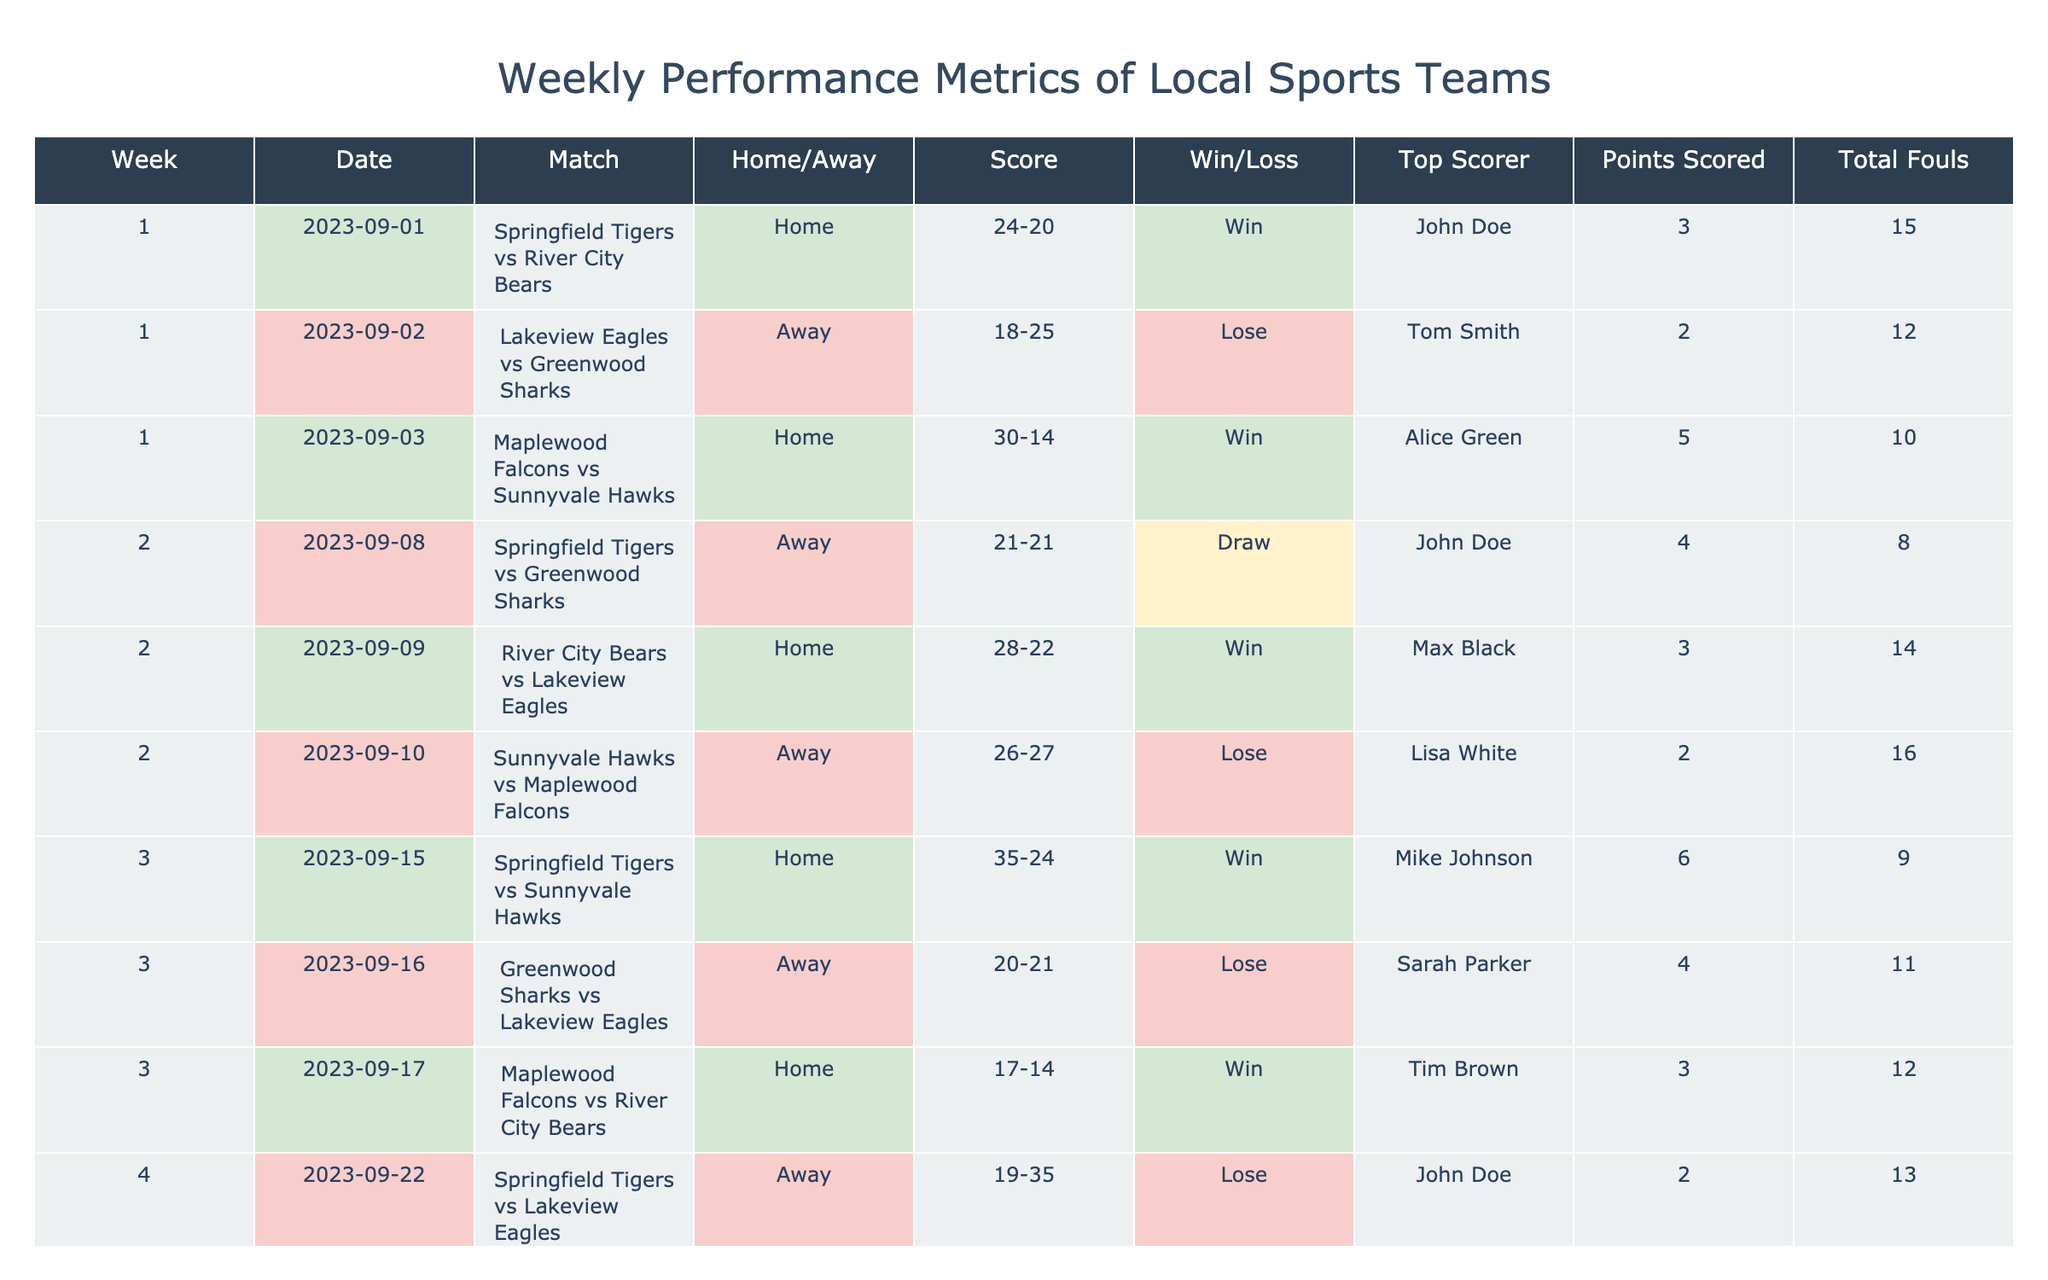What was the score of the Springfield Tigers' game against the River City Bears in Week 1? In Week 1, the Springfield Tigers played against the River City Bears, and the score listed is 24-20.
Answer: 24-20 Which team had the highest number of points scored in a single game? The Maplewood Falcons scored the highest points in a single game, with 30 points against the Sunnyvale Hawks in Week 1.
Answer: 30 Did the Lakeview Eagles win more games than they lost? The Lakeview Eagles had a total of 5 games, winning 2 and losing 3. Therefore, they lost more games than they won.
Answer: No What is the average points scored by the Springfield Tigers across all their games? The Springfield Tigers scored 24, 21, 35, 19, and 20 points in their 5 games. Summing these gives 24 + 21 + 35 + 19 + 20 = 119. Dividing by 5, the average is 119/5 = 23.8.
Answer: 23.8 In how many games did the top scorer score more than 3 points? The top scorer scored more than 3 points in 3 games: Mike Johnson scored 6 points in Week 3, Sarah Parker scored 6 points in Week 5, and John Doe scored 4 points in Week 2.
Answer: 3 Which team had the fewest total fouls in their matches? The team with the fewest total fouls is the River City Bears, with a total of 7 fouls accumulated across their games.
Answer: 7 How many games did the Springfield Tigers play at home, and what was their win-loss record in those matches? The Springfield Tigers played 3 games at home: against the River City Bears (Win), Sunnyvale Hawks (Win), and Lakeview Eagles (Lose), resulting in 2 wins and 1 loss.
Answer: 2-1 What was the outcome of the Maplewood Falcons' game against the Sunnyvale Hawks in Week 2? The Maplewood Falcons played against the Sunnyvale Hawks in Week 2 and the outcome was a loss, with the score being 26-27.
Answer: Lose 